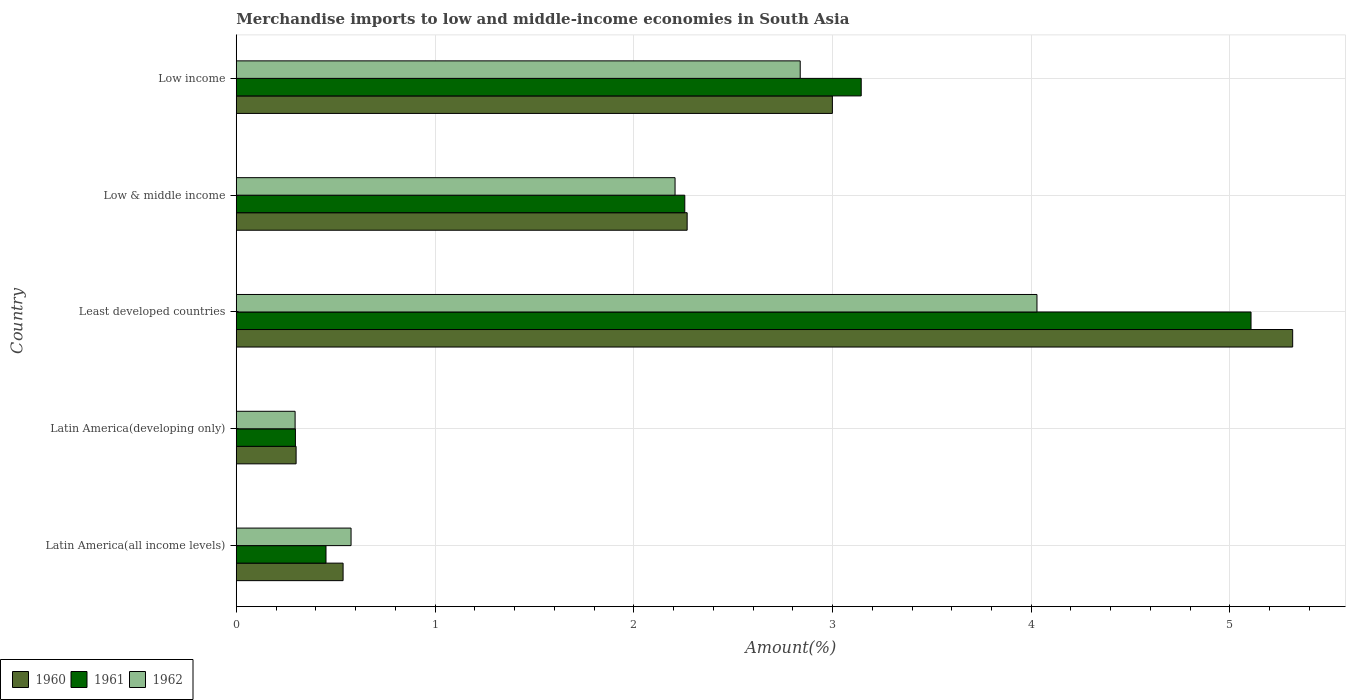Are the number of bars per tick equal to the number of legend labels?
Offer a terse response. Yes. What is the percentage of amount earned from merchandise imports in 1961 in Low & middle income?
Make the answer very short. 2.26. Across all countries, what is the maximum percentage of amount earned from merchandise imports in 1962?
Give a very brief answer. 4.03. Across all countries, what is the minimum percentage of amount earned from merchandise imports in 1960?
Provide a succinct answer. 0.3. In which country was the percentage of amount earned from merchandise imports in 1962 maximum?
Your answer should be compact. Least developed countries. In which country was the percentage of amount earned from merchandise imports in 1960 minimum?
Your response must be concise. Latin America(developing only). What is the total percentage of amount earned from merchandise imports in 1962 in the graph?
Your response must be concise. 9.95. What is the difference between the percentage of amount earned from merchandise imports in 1962 in Latin America(all income levels) and that in Low income?
Provide a succinct answer. -2.26. What is the difference between the percentage of amount earned from merchandise imports in 1960 in Low & middle income and the percentage of amount earned from merchandise imports in 1962 in Low income?
Your answer should be compact. -0.57. What is the average percentage of amount earned from merchandise imports in 1960 per country?
Offer a terse response. 2.28. What is the difference between the percentage of amount earned from merchandise imports in 1962 and percentage of amount earned from merchandise imports in 1960 in Latin America(all income levels)?
Provide a short and direct response. 0.04. What is the ratio of the percentage of amount earned from merchandise imports in 1961 in Latin America(all income levels) to that in Least developed countries?
Ensure brevity in your answer.  0.09. Is the percentage of amount earned from merchandise imports in 1961 in Latin America(all income levels) less than that in Low income?
Ensure brevity in your answer.  Yes. What is the difference between the highest and the second highest percentage of amount earned from merchandise imports in 1962?
Provide a succinct answer. 1.19. What is the difference between the highest and the lowest percentage of amount earned from merchandise imports in 1962?
Give a very brief answer. 3.73. Is the sum of the percentage of amount earned from merchandise imports in 1962 in Low & middle income and Low income greater than the maximum percentage of amount earned from merchandise imports in 1960 across all countries?
Give a very brief answer. No. What is the difference between two consecutive major ticks on the X-axis?
Provide a short and direct response. 1. Are the values on the major ticks of X-axis written in scientific E-notation?
Offer a terse response. No. What is the title of the graph?
Give a very brief answer. Merchandise imports to low and middle-income economies in South Asia. What is the label or title of the X-axis?
Offer a terse response. Amount(%). What is the Amount(%) in 1960 in Latin America(all income levels)?
Keep it short and to the point. 0.54. What is the Amount(%) of 1961 in Latin America(all income levels)?
Your response must be concise. 0.45. What is the Amount(%) of 1962 in Latin America(all income levels)?
Offer a very short reply. 0.58. What is the Amount(%) of 1960 in Latin America(developing only)?
Offer a very short reply. 0.3. What is the Amount(%) of 1961 in Latin America(developing only)?
Your answer should be very brief. 0.3. What is the Amount(%) in 1962 in Latin America(developing only)?
Your response must be concise. 0.3. What is the Amount(%) of 1960 in Least developed countries?
Your answer should be very brief. 5.32. What is the Amount(%) in 1961 in Least developed countries?
Give a very brief answer. 5.11. What is the Amount(%) of 1962 in Least developed countries?
Offer a terse response. 4.03. What is the Amount(%) of 1960 in Low & middle income?
Keep it short and to the point. 2.27. What is the Amount(%) in 1961 in Low & middle income?
Give a very brief answer. 2.26. What is the Amount(%) in 1962 in Low & middle income?
Provide a succinct answer. 2.21. What is the Amount(%) in 1960 in Low income?
Keep it short and to the point. 3. What is the Amount(%) in 1961 in Low income?
Give a very brief answer. 3.14. What is the Amount(%) of 1962 in Low income?
Your answer should be very brief. 2.84. Across all countries, what is the maximum Amount(%) in 1960?
Offer a terse response. 5.32. Across all countries, what is the maximum Amount(%) of 1961?
Keep it short and to the point. 5.11. Across all countries, what is the maximum Amount(%) in 1962?
Provide a succinct answer. 4.03. Across all countries, what is the minimum Amount(%) in 1960?
Provide a succinct answer. 0.3. Across all countries, what is the minimum Amount(%) of 1961?
Provide a short and direct response. 0.3. Across all countries, what is the minimum Amount(%) in 1962?
Your response must be concise. 0.3. What is the total Amount(%) in 1960 in the graph?
Your response must be concise. 11.42. What is the total Amount(%) in 1961 in the graph?
Keep it short and to the point. 11.26. What is the total Amount(%) of 1962 in the graph?
Give a very brief answer. 9.95. What is the difference between the Amount(%) of 1960 in Latin America(all income levels) and that in Latin America(developing only)?
Your answer should be very brief. 0.24. What is the difference between the Amount(%) in 1961 in Latin America(all income levels) and that in Latin America(developing only)?
Ensure brevity in your answer.  0.15. What is the difference between the Amount(%) of 1962 in Latin America(all income levels) and that in Latin America(developing only)?
Keep it short and to the point. 0.28. What is the difference between the Amount(%) in 1960 in Latin America(all income levels) and that in Least developed countries?
Ensure brevity in your answer.  -4.78. What is the difference between the Amount(%) in 1961 in Latin America(all income levels) and that in Least developed countries?
Your answer should be compact. -4.65. What is the difference between the Amount(%) of 1962 in Latin America(all income levels) and that in Least developed countries?
Provide a succinct answer. -3.45. What is the difference between the Amount(%) in 1960 in Latin America(all income levels) and that in Low & middle income?
Ensure brevity in your answer.  -1.73. What is the difference between the Amount(%) in 1961 in Latin America(all income levels) and that in Low & middle income?
Ensure brevity in your answer.  -1.81. What is the difference between the Amount(%) of 1962 in Latin America(all income levels) and that in Low & middle income?
Keep it short and to the point. -1.63. What is the difference between the Amount(%) in 1960 in Latin America(all income levels) and that in Low income?
Your answer should be compact. -2.46. What is the difference between the Amount(%) of 1961 in Latin America(all income levels) and that in Low income?
Your answer should be very brief. -2.69. What is the difference between the Amount(%) in 1962 in Latin America(all income levels) and that in Low income?
Your response must be concise. -2.26. What is the difference between the Amount(%) of 1960 in Latin America(developing only) and that in Least developed countries?
Give a very brief answer. -5.01. What is the difference between the Amount(%) in 1961 in Latin America(developing only) and that in Least developed countries?
Your response must be concise. -4.81. What is the difference between the Amount(%) in 1962 in Latin America(developing only) and that in Least developed countries?
Provide a succinct answer. -3.73. What is the difference between the Amount(%) in 1960 in Latin America(developing only) and that in Low & middle income?
Give a very brief answer. -1.97. What is the difference between the Amount(%) of 1961 in Latin America(developing only) and that in Low & middle income?
Your response must be concise. -1.96. What is the difference between the Amount(%) in 1962 in Latin America(developing only) and that in Low & middle income?
Make the answer very short. -1.91. What is the difference between the Amount(%) of 1960 in Latin America(developing only) and that in Low income?
Ensure brevity in your answer.  -2.7. What is the difference between the Amount(%) of 1961 in Latin America(developing only) and that in Low income?
Keep it short and to the point. -2.85. What is the difference between the Amount(%) of 1962 in Latin America(developing only) and that in Low income?
Keep it short and to the point. -2.54. What is the difference between the Amount(%) of 1960 in Least developed countries and that in Low & middle income?
Your response must be concise. 3.05. What is the difference between the Amount(%) of 1961 in Least developed countries and that in Low & middle income?
Provide a succinct answer. 2.85. What is the difference between the Amount(%) in 1962 in Least developed countries and that in Low & middle income?
Ensure brevity in your answer.  1.82. What is the difference between the Amount(%) of 1960 in Least developed countries and that in Low income?
Provide a succinct answer. 2.32. What is the difference between the Amount(%) of 1961 in Least developed countries and that in Low income?
Your response must be concise. 1.96. What is the difference between the Amount(%) in 1962 in Least developed countries and that in Low income?
Offer a terse response. 1.19. What is the difference between the Amount(%) in 1960 in Low & middle income and that in Low income?
Your answer should be compact. -0.73. What is the difference between the Amount(%) in 1961 in Low & middle income and that in Low income?
Keep it short and to the point. -0.89. What is the difference between the Amount(%) of 1962 in Low & middle income and that in Low income?
Offer a very short reply. -0.63. What is the difference between the Amount(%) of 1960 in Latin America(all income levels) and the Amount(%) of 1961 in Latin America(developing only)?
Ensure brevity in your answer.  0.24. What is the difference between the Amount(%) of 1960 in Latin America(all income levels) and the Amount(%) of 1962 in Latin America(developing only)?
Offer a very short reply. 0.24. What is the difference between the Amount(%) in 1961 in Latin America(all income levels) and the Amount(%) in 1962 in Latin America(developing only)?
Provide a short and direct response. 0.16. What is the difference between the Amount(%) of 1960 in Latin America(all income levels) and the Amount(%) of 1961 in Least developed countries?
Keep it short and to the point. -4.57. What is the difference between the Amount(%) in 1960 in Latin America(all income levels) and the Amount(%) in 1962 in Least developed countries?
Your answer should be very brief. -3.49. What is the difference between the Amount(%) of 1961 in Latin America(all income levels) and the Amount(%) of 1962 in Least developed countries?
Your answer should be very brief. -3.58. What is the difference between the Amount(%) of 1960 in Latin America(all income levels) and the Amount(%) of 1961 in Low & middle income?
Ensure brevity in your answer.  -1.72. What is the difference between the Amount(%) in 1960 in Latin America(all income levels) and the Amount(%) in 1962 in Low & middle income?
Give a very brief answer. -1.67. What is the difference between the Amount(%) of 1961 in Latin America(all income levels) and the Amount(%) of 1962 in Low & middle income?
Keep it short and to the point. -1.76. What is the difference between the Amount(%) of 1960 in Latin America(all income levels) and the Amount(%) of 1961 in Low income?
Provide a succinct answer. -2.61. What is the difference between the Amount(%) of 1960 in Latin America(all income levels) and the Amount(%) of 1962 in Low income?
Provide a succinct answer. -2.3. What is the difference between the Amount(%) in 1961 in Latin America(all income levels) and the Amount(%) in 1962 in Low income?
Keep it short and to the point. -2.39. What is the difference between the Amount(%) of 1960 in Latin America(developing only) and the Amount(%) of 1961 in Least developed countries?
Offer a very short reply. -4.8. What is the difference between the Amount(%) in 1960 in Latin America(developing only) and the Amount(%) in 1962 in Least developed countries?
Give a very brief answer. -3.73. What is the difference between the Amount(%) of 1961 in Latin America(developing only) and the Amount(%) of 1962 in Least developed countries?
Provide a short and direct response. -3.73. What is the difference between the Amount(%) of 1960 in Latin America(developing only) and the Amount(%) of 1961 in Low & middle income?
Provide a short and direct response. -1.96. What is the difference between the Amount(%) in 1960 in Latin America(developing only) and the Amount(%) in 1962 in Low & middle income?
Provide a succinct answer. -1.91. What is the difference between the Amount(%) in 1961 in Latin America(developing only) and the Amount(%) in 1962 in Low & middle income?
Provide a succinct answer. -1.91. What is the difference between the Amount(%) in 1960 in Latin America(developing only) and the Amount(%) in 1961 in Low income?
Your answer should be compact. -2.84. What is the difference between the Amount(%) of 1960 in Latin America(developing only) and the Amount(%) of 1962 in Low income?
Offer a very short reply. -2.54. What is the difference between the Amount(%) in 1961 in Latin America(developing only) and the Amount(%) in 1962 in Low income?
Provide a succinct answer. -2.54. What is the difference between the Amount(%) of 1960 in Least developed countries and the Amount(%) of 1961 in Low & middle income?
Make the answer very short. 3.06. What is the difference between the Amount(%) of 1960 in Least developed countries and the Amount(%) of 1962 in Low & middle income?
Your answer should be very brief. 3.11. What is the difference between the Amount(%) in 1961 in Least developed countries and the Amount(%) in 1962 in Low & middle income?
Your answer should be compact. 2.9. What is the difference between the Amount(%) of 1960 in Least developed countries and the Amount(%) of 1961 in Low income?
Provide a short and direct response. 2.17. What is the difference between the Amount(%) of 1960 in Least developed countries and the Amount(%) of 1962 in Low income?
Keep it short and to the point. 2.48. What is the difference between the Amount(%) of 1961 in Least developed countries and the Amount(%) of 1962 in Low income?
Your response must be concise. 2.27. What is the difference between the Amount(%) of 1960 in Low & middle income and the Amount(%) of 1961 in Low income?
Provide a succinct answer. -0.88. What is the difference between the Amount(%) in 1960 in Low & middle income and the Amount(%) in 1962 in Low income?
Offer a very short reply. -0.57. What is the difference between the Amount(%) in 1961 in Low & middle income and the Amount(%) in 1962 in Low income?
Keep it short and to the point. -0.58. What is the average Amount(%) in 1960 per country?
Make the answer very short. 2.28. What is the average Amount(%) of 1961 per country?
Your answer should be compact. 2.25. What is the average Amount(%) in 1962 per country?
Make the answer very short. 1.99. What is the difference between the Amount(%) in 1960 and Amount(%) in 1961 in Latin America(all income levels)?
Offer a very short reply. 0.09. What is the difference between the Amount(%) of 1960 and Amount(%) of 1962 in Latin America(all income levels)?
Ensure brevity in your answer.  -0.04. What is the difference between the Amount(%) in 1961 and Amount(%) in 1962 in Latin America(all income levels)?
Your answer should be very brief. -0.13. What is the difference between the Amount(%) in 1960 and Amount(%) in 1961 in Latin America(developing only)?
Give a very brief answer. 0. What is the difference between the Amount(%) of 1960 and Amount(%) of 1962 in Latin America(developing only)?
Offer a terse response. 0.01. What is the difference between the Amount(%) in 1961 and Amount(%) in 1962 in Latin America(developing only)?
Make the answer very short. 0. What is the difference between the Amount(%) in 1960 and Amount(%) in 1961 in Least developed countries?
Ensure brevity in your answer.  0.21. What is the difference between the Amount(%) in 1960 and Amount(%) in 1962 in Least developed countries?
Keep it short and to the point. 1.29. What is the difference between the Amount(%) of 1961 and Amount(%) of 1962 in Least developed countries?
Keep it short and to the point. 1.08. What is the difference between the Amount(%) in 1960 and Amount(%) in 1961 in Low & middle income?
Ensure brevity in your answer.  0.01. What is the difference between the Amount(%) in 1960 and Amount(%) in 1962 in Low & middle income?
Provide a short and direct response. 0.06. What is the difference between the Amount(%) of 1961 and Amount(%) of 1962 in Low & middle income?
Keep it short and to the point. 0.05. What is the difference between the Amount(%) in 1960 and Amount(%) in 1961 in Low income?
Offer a very short reply. -0.15. What is the difference between the Amount(%) in 1960 and Amount(%) in 1962 in Low income?
Make the answer very short. 0.16. What is the difference between the Amount(%) in 1961 and Amount(%) in 1962 in Low income?
Give a very brief answer. 0.31. What is the ratio of the Amount(%) of 1960 in Latin America(all income levels) to that in Latin America(developing only)?
Make the answer very short. 1.78. What is the ratio of the Amount(%) in 1961 in Latin America(all income levels) to that in Latin America(developing only)?
Make the answer very short. 1.52. What is the ratio of the Amount(%) in 1962 in Latin America(all income levels) to that in Latin America(developing only)?
Your answer should be very brief. 1.95. What is the ratio of the Amount(%) in 1960 in Latin America(all income levels) to that in Least developed countries?
Provide a short and direct response. 0.1. What is the ratio of the Amount(%) in 1961 in Latin America(all income levels) to that in Least developed countries?
Give a very brief answer. 0.09. What is the ratio of the Amount(%) of 1962 in Latin America(all income levels) to that in Least developed countries?
Offer a terse response. 0.14. What is the ratio of the Amount(%) of 1960 in Latin America(all income levels) to that in Low & middle income?
Offer a terse response. 0.24. What is the ratio of the Amount(%) in 1961 in Latin America(all income levels) to that in Low & middle income?
Offer a very short reply. 0.2. What is the ratio of the Amount(%) of 1962 in Latin America(all income levels) to that in Low & middle income?
Make the answer very short. 0.26. What is the ratio of the Amount(%) of 1960 in Latin America(all income levels) to that in Low income?
Offer a terse response. 0.18. What is the ratio of the Amount(%) of 1961 in Latin America(all income levels) to that in Low income?
Make the answer very short. 0.14. What is the ratio of the Amount(%) of 1962 in Latin America(all income levels) to that in Low income?
Offer a terse response. 0.2. What is the ratio of the Amount(%) in 1960 in Latin America(developing only) to that in Least developed countries?
Ensure brevity in your answer.  0.06. What is the ratio of the Amount(%) of 1961 in Latin America(developing only) to that in Least developed countries?
Keep it short and to the point. 0.06. What is the ratio of the Amount(%) in 1962 in Latin America(developing only) to that in Least developed countries?
Make the answer very short. 0.07. What is the ratio of the Amount(%) of 1960 in Latin America(developing only) to that in Low & middle income?
Your answer should be compact. 0.13. What is the ratio of the Amount(%) of 1961 in Latin America(developing only) to that in Low & middle income?
Provide a succinct answer. 0.13. What is the ratio of the Amount(%) in 1962 in Latin America(developing only) to that in Low & middle income?
Make the answer very short. 0.13. What is the ratio of the Amount(%) of 1960 in Latin America(developing only) to that in Low income?
Keep it short and to the point. 0.1. What is the ratio of the Amount(%) in 1961 in Latin America(developing only) to that in Low income?
Your answer should be compact. 0.09. What is the ratio of the Amount(%) of 1962 in Latin America(developing only) to that in Low income?
Keep it short and to the point. 0.1. What is the ratio of the Amount(%) in 1960 in Least developed countries to that in Low & middle income?
Your response must be concise. 2.34. What is the ratio of the Amount(%) of 1961 in Least developed countries to that in Low & middle income?
Make the answer very short. 2.26. What is the ratio of the Amount(%) in 1962 in Least developed countries to that in Low & middle income?
Give a very brief answer. 1.82. What is the ratio of the Amount(%) in 1960 in Least developed countries to that in Low income?
Your answer should be compact. 1.77. What is the ratio of the Amount(%) in 1961 in Least developed countries to that in Low income?
Provide a short and direct response. 1.62. What is the ratio of the Amount(%) of 1962 in Least developed countries to that in Low income?
Ensure brevity in your answer.  1.42. What is the ratio of the Amount(%) of 1960 in Low & middle income to that in Low income?
Ensure brevity in your answer.  0.76. What is the ratio of the Amount(%) of 1961 in Low & middle income to that in Low income?
Make the answer very short. 0.72. What is the ratio of the Amount(%) of 1962 in Low & middle income to that in Low income?
Ensure brevity in your answer.  0.78. What is the difference between the highest and the second highest Amount(%) of 1960?
Provide a succinct answer. 2.32. What is the difference between the highest and the second highest Amount(%) of 1961?
Provide a succinct answer. 1.96. What is the difference between the highest and the second highest Amount(%) in 1962?
Offer a terse response. 1.19. What is the difference between the highest and the lowest Amount(%) of 1960?
Your answer should be compact. 5.01. What is the difference between the highest and the lowest Amount(%) of 1961?
Your response must be concise. 4.81. What is the difference between the highest and the lowest Amount(%) in 1962?
Your response must be concise. 3.73. 